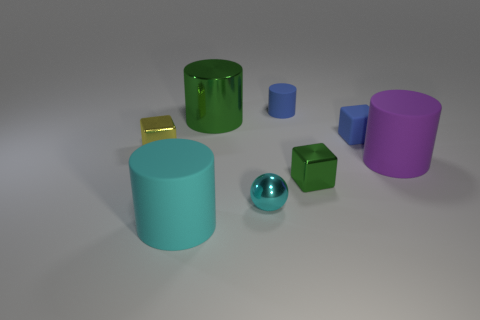What is the shape of the small thing that is the same color as the small cylinder?
Provide a short and direct response. Cube. Is there a metal thing that has the same color as the shiny cylinder?
Ensure brevity in your answer.  Yes. Is the tiny rubber block the same color as the tiny rubber cylinder?
Your answer should be very brief. Yes. What is the shape of the purple object that is the same size as the cyan matte object?
Provide a short and direct response. Cylinder. How big is the purple object?
Provide a succinct answer. Large. There is a block in front of the yellow block; is its size the same as the matte cylinder that is in front of the purple matte cylinder?
Give a very brief answer. No. What is the color of the tiny metallic block that is in front of the large matte cylinder that is right of the tiny blue rubber cube?
Ensure brevity in your answer.  Green. There is a cyan cylinder that is the same size as the purple thing; what is it made of?
Ensure brevity in your answer.  Rubber. What number of metallic things are either tiny objects or cyan balls?
Make the answer very short. 3. What is the color of the shiny object that is behind the metal sphere and on the right side of the big shiny cylinder?
Your answer should be compact. Green. 